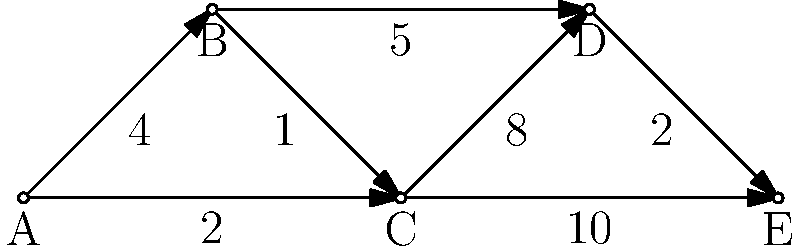In the network diagram representing communication channels between polarized communities, what is the shortest path from community A to community E, and what is its total weight? To find the shortest path from A to E, we'll use Dijkstra's algorithm:

1) Initialize:
   - Distance to A: 0
   - Distance to all other nodes: infinity
   - Previous node for all: undefined

2) Visit A:
   - Update B: distance 4, previous A
   - Update C: distance 2, previous A

3) Visit C (closest unvisited):
   - Update B: no change (4 < 2+1)
   - Update D: distance 10 (2+8), previous C
   - Update E: distance 12 (2+10), previous C

4) Visit B:
   - Update D: distance 9 (4+5), previous B

5) Visit D:
   - Update E: distance 11 (9+2), previous D

6) Visit E (destination reached)

The shortest path is A → C → B → D → E with a total weight of 11.

Path breakdown:
A → C: 2
C → B: 1
B → D: 5
D → E: 2
Total: 2 + 1 + 5 + 2 = 11
Answer: A → C → B → D → E, weight 11 